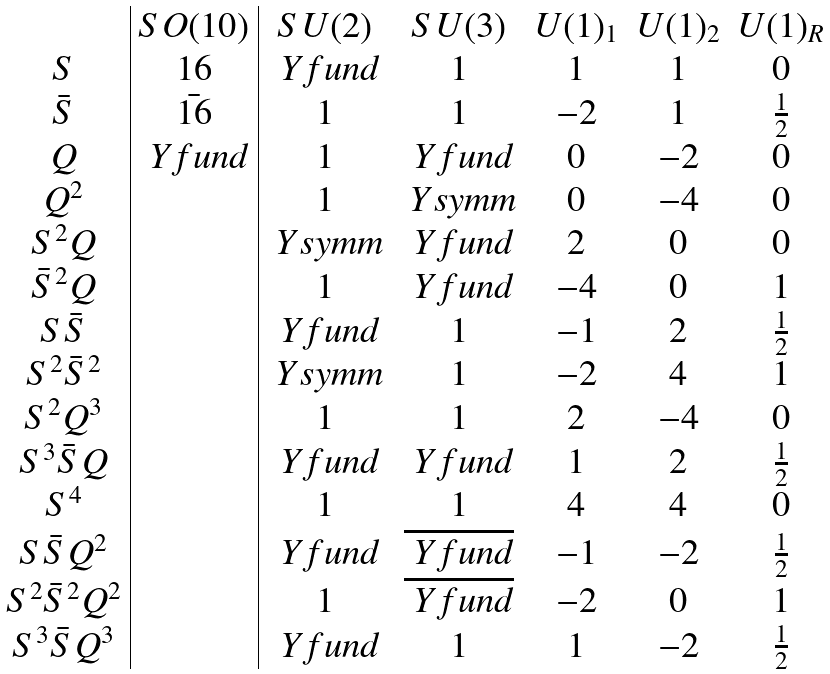<formula> <loc_0><loc_0><loc_500><loc_500>\begin{array} { c | c | c c c c c } & S O ( 1 0 ) & S U ( 2 ) & S U ( 3 ) & U ( 1 ) _ { 1 } & U ( 1 ) _ { 2 } & U ( 1 ) _ { R } \\ S & 1 6 & \ Y f u n d & 1 & 1 & 1 & 0 \\ \bar { S } & \bar { 1 6 } & 1 & 1 & - 2 & 1 & \frac { 1 } { 2 } \\ Q & \ Y f u n d & 1 & \ Y f u n d & 0 & - 2 & 0 \\ Q ^ { 2 } & & 1 & \ Y s y m m & 0 & - 4 & 0 \\ S ^ { 2 } Q & & \ Y s y m m & \ Y f u n d & 2 & 0 & 0 \\ \bar { S } ^ { 2 } Q & & 1 & \ Y f u n d & - 4 & 0 & 1 \\ S \bar { S } & & \ Y f u n d & 1 & - 1 & 2 & \frac { 1 } { 2 } \\ S ^ { 2 } \bar { S } ^ { 2 } & & \ Y s y m m & 1 & - 2 & 4 & 1 \\ S ^ { 2 } Q ^ { 3 } & & 1 & 1 & 2 & - 4 & 0 \\ S ^ { 3 } \bar { S } Q & & \ Y f u n d & \ Y f u n d & 1 & 2 & \frac { 1 } { 2 } \\ S ^ { 4 } & & 1 & 1 & 4 & 4 & 0 \\ S \bar { S } Q ^ { 2 } & & \ Y f u n d & \overline { \ Y f u n d } & - 1 & - 2 & \frac { 1 } { 2 } \\ S ^ { 2 } \bar { S } ^ { 2 } Q ^ { 2 } & & 1 & \overline { \ Y f u n d } & - 2 & 0 & 1 \\ S ^ { 3 } \bar { S } Q ^ { 3 } & & \ Y f u n d & 1 & 1 & - 2 & \frac { 1 } { 2 } \end{array}</formula> 